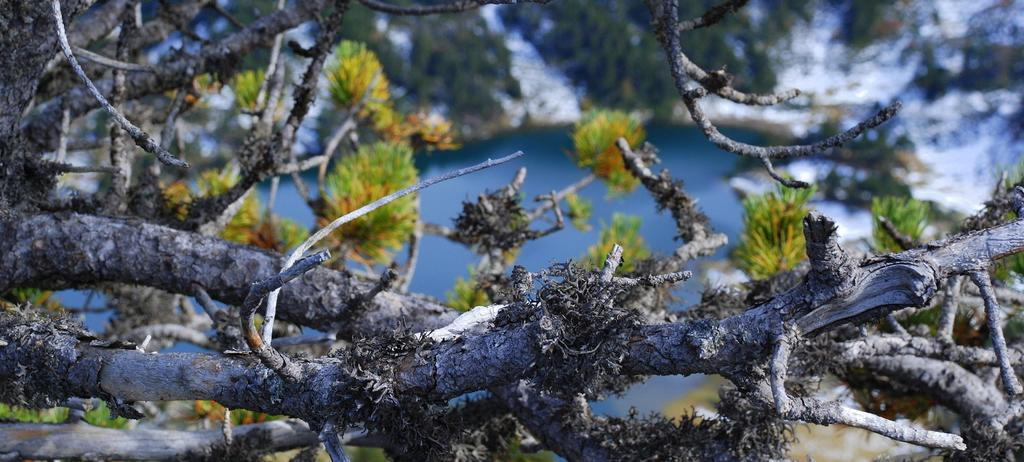What type of vegetation can be seen in the image? There are leaves and branches in the image. What natural element is visible in the image? There is water visible in the image. How would you describe the background of the image? The background of the image is blurry. What type of juice is being requested in the image? There is no mention of juice or a request in the image. 